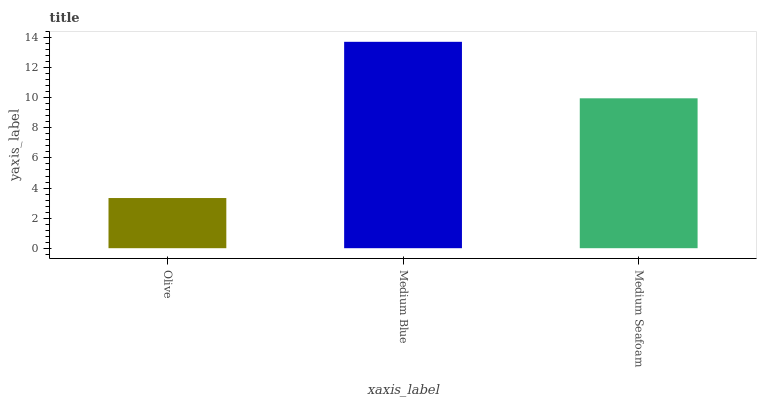Is Olive the minimum?
Answer yes or no. Yes. Is Medium Blue the maximum?
Answer yes or no. Yes. Is Medium Seafoam the minimum?
Answer yes or no. No. Is Medium Seafoam the maximum?
Answer yes or no. No. Is Medium Blue greater than Medium Seafoam?
Answer yes or no. Yes. Is Medium Seafoam less than Medium Blue?
Answer yes or no. Yes. Is Medium Seafoam greater than Medium Blue?
Answer yes or no. No. Is Medium Blue less than Medium Seafoam?
Answer yes or no. No. Is Medium Seafoam the high median?
Answer yes or no. Yes. Is Medium Seafoam the low median?
Answer yes or no. Yes. Is Medium Blue the high median?
Answer yes or no. No. Is Medium Blue the low median?
Answer yes or no. No. 